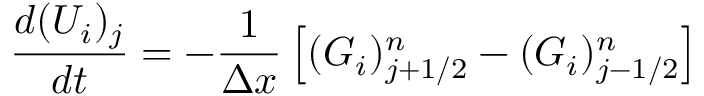<formula> <loc_0><loc_0><loc_500><loc_500>\frac { d ( U _ { i } ) _ { j } } { d t } = - \frac { 1 } { \Delta x } \left [ ( G _ { i } ) _ { j + 1 / 2 } ^ { n } - ( G _ { i } ) _ { j - 1 / 2 } ^ { n } \right ]</formula> 